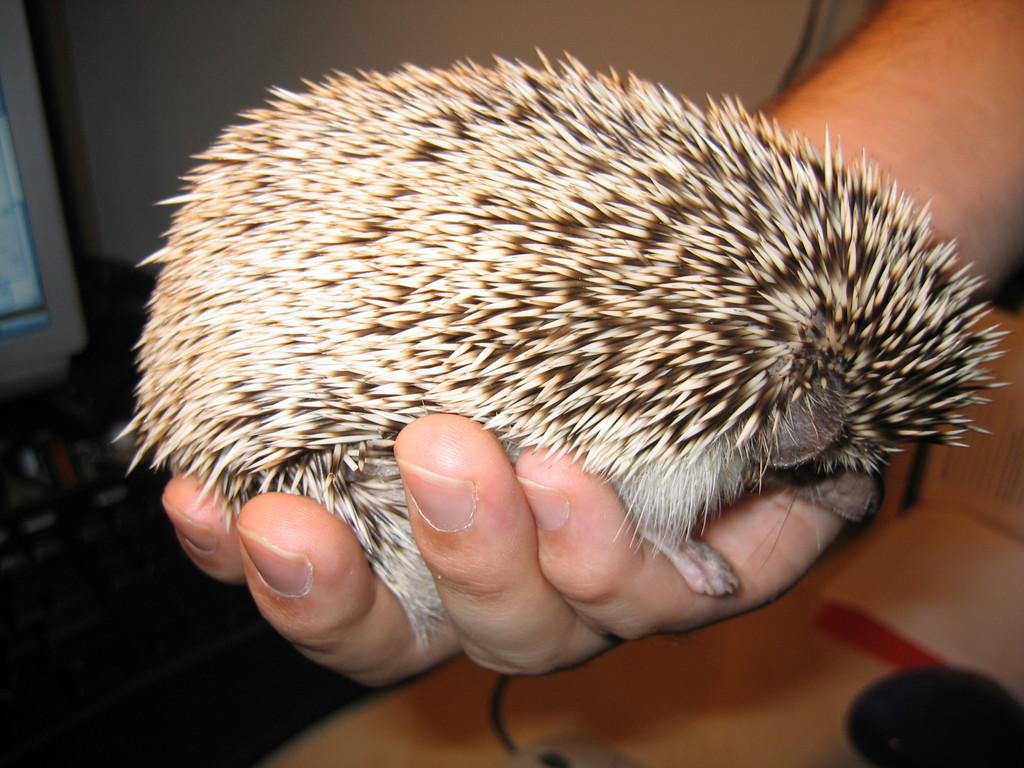What is the person's hand doing in the image? The person's hand is holding an animal in the image. What other objects or furniture can be seen in the image? There is a table in the image, and a book is present on the table. What part of the room is visible in the image? The wall is visible at the top of the image. What type of vacation is the person planning based on the image? There is no information about a vacation in the image, as it only shows a person's hand holding an animal, a table, a book, and a visible wall. 